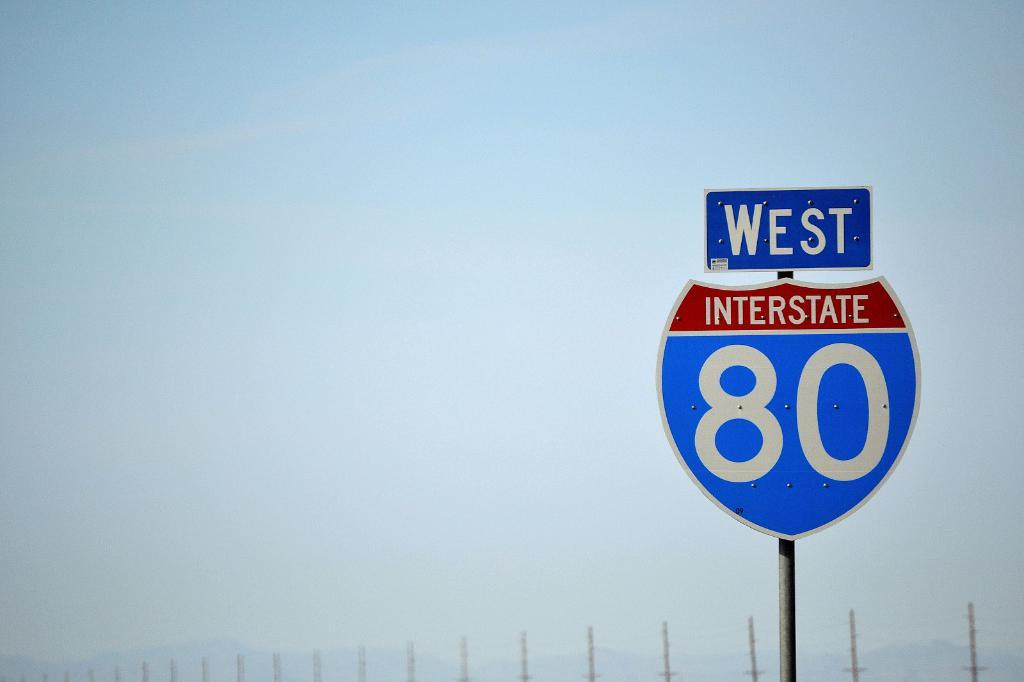<image>
Write a terse but informative summary of the picture. A sign for West Interstate 80 is visible on a cloudy day. 